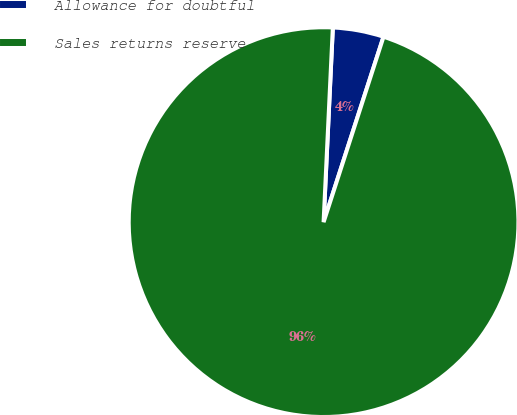Convert chart. <chart><loc_0><loc_0><loc_500><loc_500><pie_chart><fcel>Allowance for doubtful<fcel>Sales returns reserve<nl><fcel>4.22%<fcel>95.78%<nl></chart> 